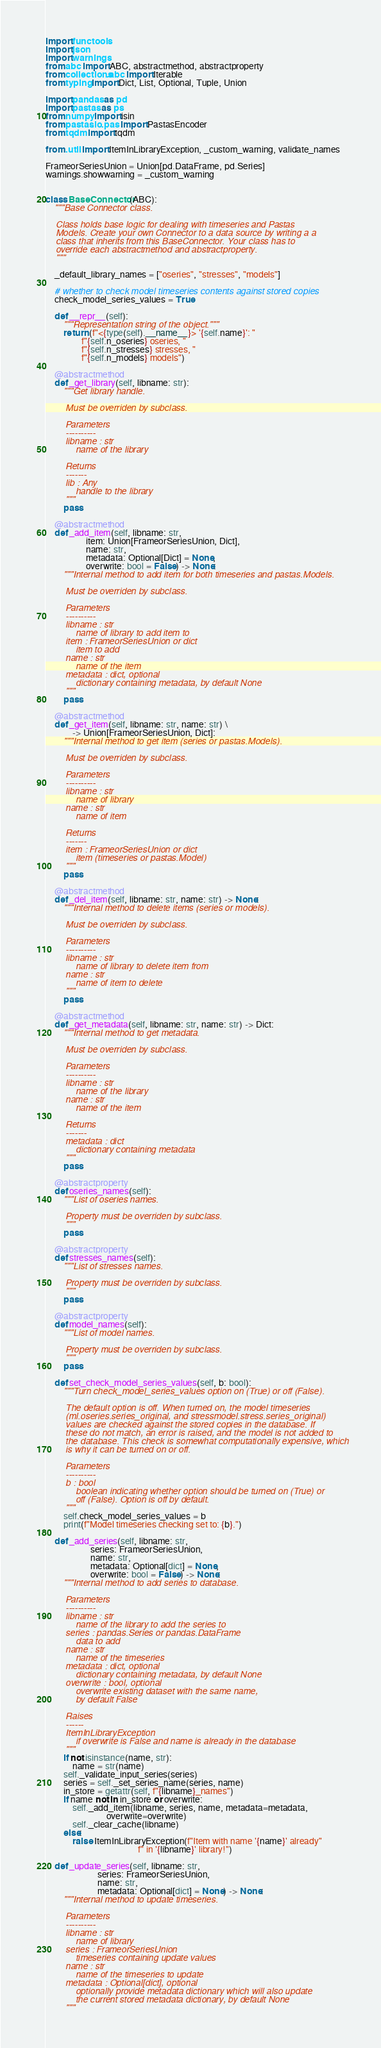Convert code to text. <code><loc_0><loc_0><loc_500><loc_500><_Python_>import functools
import json
import warnings
from abc import ABC, abstractmethod, abstractproperty
from collections.abc import Iterable
from typing import Dict, List, Optional, Tuple, Union

import pandas as pd
import pastas as ps
from numpy import isin
from pastas.io.pas import PastasEncoder
from tqdm import tqdm

from .util import ItemInLibraryException, _custom_warning, validate_names

FrameorSeriesUnion = Union[pd.DataFrame, pd.Series]
warnings.showwarning = _custom_warning


class BaseConnector(ABC):
    """Base Connector class.

    Class holds base logic for dealing with timeseries and Pastas
    Models. Create your own Connector to a data source by writing a a
    class that inherits from this BaseConnector. Your class has to
    override each abstractmethod and abstractproperty.
    """

    _default_library_names = ["oseries", "stresses", "models"]

    # whether to check model timeseries contents against stored copies
    check_model_series_values = True

    def __repr__(self):
        """Representation string of the object."""
        return (f"<{type(self).__name__}> '{self.name}': "
                f"{self.n_oseries} oseries, "
                f"{self.n_stresses} stresses, "
                f"{self.n_models} models")

    @abstractmethod
    def _get_library(self, libname: str):
        """Get library handle.

        Must be overriden by subclass.

        Parameters
        ----------
        libname : str
            name of the library

        Returns
        -------
        lib : Any
            handle to the library
        """
        pass

    @abstractmethod
    def _add_item(self, libname: str,
                  item: Union[FrameorSeriesUnion, Dict],
                  name: str,
                  metadata: Optional[Dict] = None,
                  overwrite: bool = False) -> None:
        """Internal method to add item for both timeseries and pastas.Models.

        Must be overriden by subclass.

        Parameters
        ----------
        libname : str
            name of library to add item to
        item : FrameorSeriesUnion or dict
            item to add
        name : str
            name of the item
        metadata : dict, optional
            dictionary containing metadata, by default None
        """
        pass

    @abstractmethod
    def _get_item(self, libname: str, name: str) \
            -> Union[FrameorSeriesUnion, Dict]:
        """Internal method to get item (series or pastas.Models).

        Must be overriden by subclass.

        Parameters
        ----------
        libname : str
            name of library
        name : str
            name of item

        Returns
        -------
        item : FrameorSeriesUnion or dict
            item (timeseries or pastas.Model)
        """
        pass

    @abstractmethod
    def _del_item(self, libname: str, name: str) -> None:
        """Internal method to delete items (series or models).

        Must be overriden by subclass.

        Parameters
        ----------
        libname : str
            name of library to delete item from
        name : str
            name of item to delete
        """
        pass

    @abstractmethod
    def _get_metadata(self, libname: str, name: str) -> Dict:
        """Internal method to get metadata.

        Must be overriden by subclass.

        Parameters
        ----------
        libname : str
            name of the library
        name : str
            name of the item

        Returns
        -------
        metadata : dict
            dictionary containing metadata
        """
        pass

    @abstractproperty
    def oseries_names(self):
        """List of oseries names.

        Property must be overriden by subclass.
        """
        pass

    @abstractproperty
    def stresses_names(self):
        """List of stresses names.

        Property must be overriden by subclass.
        """
        pass

    @abstractproperty
    def model_names(self):
        """List of model names.

        Property must be overriden by subclass.
        """
        pass

    def set_check_model_series_values(self, b: bool):
        """Turn check_model_series_values option on (True) or off (False).

        The default option is off. When turned on, the model timeseries
        (ml.oseries.series_original, and stressmodel.stress.series_original)
        values are checked against the stored copies in the database. If
        these do not match, an error is raised, and the model is not added to
        the database. This check is somewhat computationally expensive, which
        is why it can be turned on or off.

        Parameters
        ----------
        b : bool
            boolean indicating whether option should be turned on (True) or
            off (False). Option is off by default.
        """
        self.check_model_series_values = b
        print(f"Model timeseries checking set to: {b}.")

    def _add_series(self, libname: str,
                    series: FrameorSeriesUnion,
                    name: str,
                    metadata: Optional[dict] = None,
                    overwrite: bool = False) -> None:
        """Internal method to add series to database.

        Parameters
        ----------
        libname : str
            name of the library to add the series to
        series : pandas.Series or pandas.DataFrame
            data to add
        name : str
            name of the timeseries
        metadata : dict, optional
            dictionary containing metadata, by default None
        overwrite : bool, optional
            overwrite existing dataset with the same name,
            by default False

        Raises
        ------
        ItemInLibraryException
            if overwrite is False and name is already in the database
        """
        if not isinstance(name, str):
            name = str(name)
        self._validate_input_series(series)
        series = self._set_series_name(series, name)
        in_store = getattr(self, f"{libname}_names")
        if name not in in_store or overwrite:
            self._add_item(libname, series, name, metadata=metadata,
                           overwrite=overwrite)
            self._clear_cache(libname)
        else:
            raise ItemInLibraryException(f"Item with name '{name}' already"
                                         f" in '{libname}' library!")

    def _update_series(self, libname: str,
                       series: FrameorSeriesUnion,
                       name: str,
                       metadata: Optional[dict] = None) -> None:
        """Internal method to update timeseries.

        Parameters
        ----------
        libname : str
            name of library
        series : FrameorSeriesUnion
            timeseries containing update values
        name : str
            name of the timeseries to update
        metadata : Optional[dict], optional
            optionally provide metadata dictionary which will also update
            the current stored metadata dictionary, by default None
        """</code> 